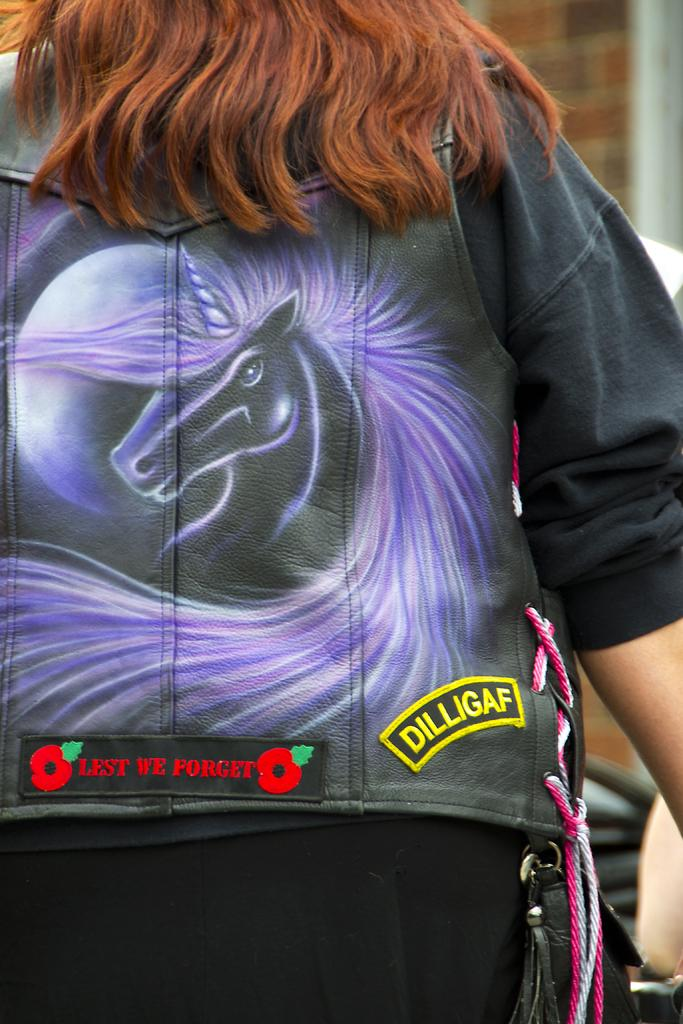What is the main subject of the image? There is a person in the image. What is the person wearing? The person is wearing a black jacket and black pants. Is there any text or writing on the person's clothing? Yes, there is something written on the jacket. What type of laborer is working in the library in the image? There is no laborer or library present in the image; it features a person wearing a black jacket and black pants with writing on the jacket. 